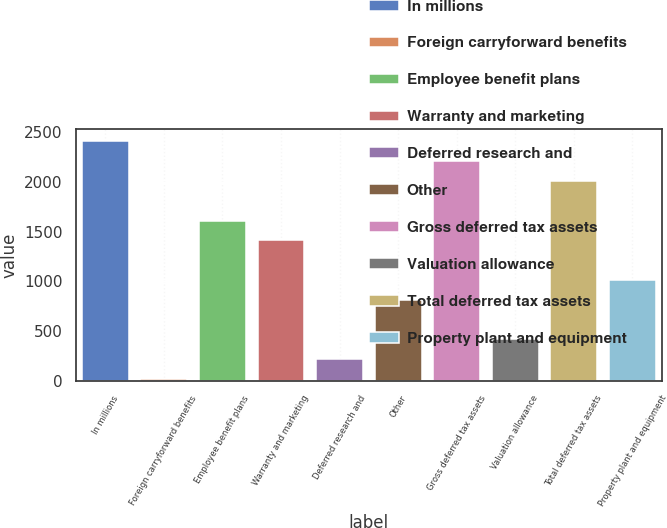<chart> <loc_0><loc_0><loc_500><loc_500><bar_chart><fcel>In millions<fcel>Foreign carryforward benefits<fcel>Employee benefit plans<fcel>Warranty and marketing<fcel>Deferred research and<fcel>Other<fcel>Gross deferred tax assets<fcel>Valuation allowance<fcel>Total deferred tax assets<fcel>Property plant and equipment<nl><fcel>2406.8<fcel>20<fcel>1611.2<fcel>1412.3<fcel>218.9<fcel>815.6<fcel>2207.9<fcel>417.8<fcel>2009<fcel>1014.5<nl></chart> 